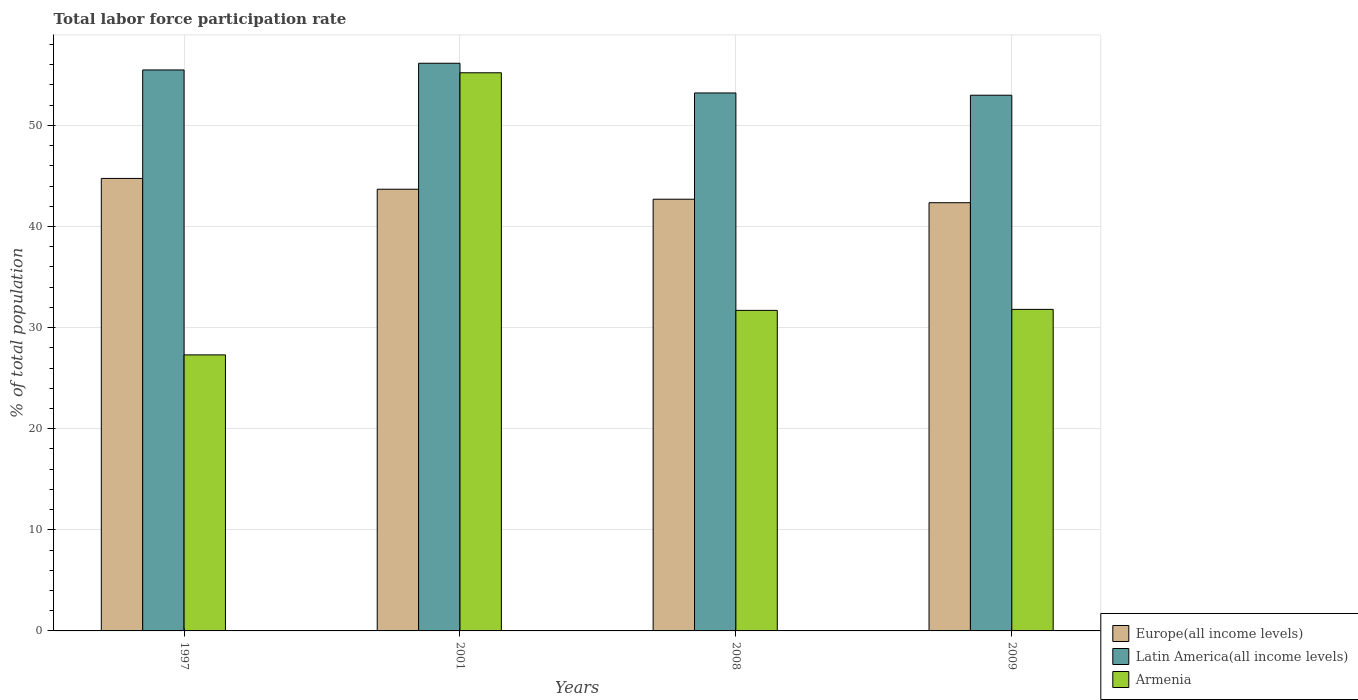How many different coloured bars are there?
Ensure brevity in your answer.  3. How many groups of bars are there?
Your answer should be compact. 4. Are the number of bars per tick equal to the number of legend labels?
Your response must be concise. Yes. How many bars are there on the 3rd tick from the left?
Make the answer very short. 3. What is the label of the 4th group of bars from the left?
Your answer should be very brief. 2009. In how many cases, is the number of bars for a given year not equal to the number of legend labels?
Your answer should be very brief. 0. What is the total labor force participation rate in Europe(all income levels) in 2001?
Offer a terse response. 43.68. Across all years, what is the maximum total labor force participation rate in Armenia?
Ensure brevity in your answer.  55.2. Across all years, what is the minimum total labor force participation rate in Armenia?
Offer a very short reply. 27.3. In which year was the total labor force participation rate in Armenia maximum?
Your answer should be compact. 2001. What is the total total labor force participation rate in Armenia in the graph?
Make the answer very short. 146. What is the difference between the total labor force participation rate in Latin America(all income levels) in 2001 and that in 2009?
Your answer should be very brief. 3.16. What is the difference between the total labor force participation rate in Armenia in 2001 and the total labor force participation rate in Latin America(all income levels) in 2009?
Your answer should be compact. 2.22. What is the average total labor force participation rate in Latin America(all income levels) per year?
Keep it short and to the point. 54.45. In the year 2008, what is the difference between the total labor force participation rate in Armenia and total labor force participation rate in Europe(all income levels)?
Keep it short and to the point. -10.99. What is the ratio of the total labor force participation rate in Latin America(all income levels) in 2008 to that in 2009?
Your response must be concise. 1. What is the difference between the highest and the second highest total labor force participation rate in Latin America(all income levels)?
Provide a succinct answer. 0.66. What is the difference between the highest and the lowest total labor force participation rate in Latin America(all income levels)?
Ensure brevity in your answer.  3.16. What does the 1st bar from the left in 2009 represents?
Provide a short and direct response. Europe(all income levels). What does the 3rd bar from the right in 2008 represents?
Keep it short and to the point. Europe(all income levels). How many bars are there?
Make the answer very short. 12. Are all the bars in the graph horizontal?
Offer a terse response. No. Does the graph contain grids?
Offer a terse response. Yes. Where does the legend appear in the graph?
Your answer should be very brief. Bottom right. How are the legend labels stacked?
Give a very brief answer. Vertical. What is the title of the graph?
Your answer should be compact. Total labor force participation rate. Does "Vietnam" appear as one of the legend labels in the graph?
Provide a short and direct response. No. What is the label or title of the X-axis?
Your response must be concise. Years. What is the label or title of the Y-axis?
Offer a very short reply. % of total population. What is the % of total population of Europe(all income levels) in 1997?
Give a very brief answer. 44.75. What is the % of total population of Latin America(all income levels) in 1997?
Your response must be concise. 55.48. What is the % of total population in Armenia in 1997?
Give a very brief answer. 27.3. What is the % of total population of Europe(all income levels) in 2001?
Provide a short and direct response. 43.68. What is the % of total population of Latin America(all income levels) in 2001?
Offer a very short reply. 56.14. What is the % of total population of Armenia in 2001?
Keep it short and to the point. 55.2. What is the % of total population in Europe(all income levels) in 2008?
Ensure brevity in your answer.  42.69. What is the % of total population of Latin America(all income levels) in 2008?
Make the answer very short. 53.2. What is the % of total population in Armenia in 2008?
Make the answer very short. 31.7. What is the % of total population in Europe(all income levels) in 2009?
Your response must be concise. 42.35. What is the % of total population of Latin America(all income levels) in 2009?
Keep it short and to the point. 52.98. What is the % of total population of Armenia in 2009?
Your answer should be compact. 31.8. Across all years, what is the maximum % of total population of Europe(all income levels)?
Provide a succinct answer. 44.75. Across all years, what is the maximum % of total population in Latin America(all income levels)?
Provide a succinct answer. 56.14. Across all years, what is the maximum % of total population of Armenia?
Provide a succinct answer. 55.2. Across all years, what is the minimum % of total population of Europe(all income levels)?
Your answer should be very brief. 42.35. Across all years, what is the minimum % of total population of Latin America(all income levels)?
Provide a succinct answer. 52.98. Across all years, what is the minimum % of total population in Armenia?
Give a very brief answer. 27.3. What is the total % of total population in Europe(all income levels) in the graph?
Provide a succinct answer. 173.48. What is the total % of total population in Latin America(all income levels) in the graph?
Provide a succinct answer. 217.8. What is the total % of total population in Armenia in the graph?
Ensure brevity in your answer.  146. What is the difference between the % of total population in Europe(all income levels) in 1997 and that in 2001?
Your answer should be very brief. 1.07. What is the difference between the % of total population of Latin America(all income levels) in 1997 and that in 2001?
Ensure brevity in your answer.  -0.66. What is the difference between the % of total population in Armenia in 1997 and that in 2001?
Your answer should be compact. -27.9. What is the difference between the % of total population of Europe(all income levels) in 1997 and that in 2008?
Your response must be concise. 2.06. What is the difference between the % of total population in Latin America(all income levels) in 1997 and that in 2008?
Provide a short and direct response. 2.27. What is the difference between the % of total population of Europe(all income levels) in 1997 and that in 2009?
Your response must be concise. 2.4. What is the difference between the % of total population of Latin America(all income levels) in 1997 and that in 2009?
Your answer should be compact. 2.5. What is the difference between the % of total population in Armenia in 1997 and that in 2009?
Offer a very short reply. -4.5. What is the difference between the % of total population of Europe(all income levels) in 2001 and that in 2008?
Your response must be concise. 0.99. What is the difference between the % of total population in Latin America(all income levels) in 2001 and that in 2008?
Offer a very short reply. 2.94. What is the difference between the % of total population in Armenia in 2001 and that in 2008?
Ensure brevity in your answer.  23.5. What is the difference between the % of total population in Europe(all income levels) in 2001 and that in 2009?
Your answer should be compact. 1.33. What is the difference between the % of total population of Latin America(all income levels) in 2001 and that in 2009?
Provide a succinct answer. 3.16. What is the difference between the % of total population in Armenia in 2001 and that in 2009?
Your answer should be compact. 23.4. What is the difference between the % of total population of Europe(all income levels) in 2008 and that in 2009?
Your response must be concise. 0.34. What is the difference between the % of total population of Latin America(all income levels) in 2008 and that in 2009?
Your answer should be compact. 0.23. What is the difference between the % of total population in Europe(all income levels) in 1997 and the % of total population in Latin America(all income levels) in 2001?
Offer a terse response. -11.39. What is the difference between the % of total population in Europe(all income levels) in 1997 and the % of total population in Armenia in 2001?
Give a very brief answer. -10.45. What is the difference between the % of total population of Latin America(all income levels) in 1997 and the % of total population of Armenia in 2001?
Provide a short and direct response. 0.28. What is the difference between the % of total population in Europe(all income levels) in 1997 and the % of total population in Latin America(all income levels) in 2008?
Your answer should be very brief. -8.45. What is the difference between the % of total population of Europe(all income levels) in 1997 and the % of total population of Armenia in 2008?
Your response must be concise. 13.05. What is the difference between the % of total population of Latin America(all income levels) in 1997 and the % of total population of Armenia in 2008?
Your answer should be compact. 23.78. What is the difference between the % of total population of Europe(all income levels) in 1997 and the % of total population of Latin America(all income levels) in 2009?
Provide a succinct answer. -8.23. What is the difference between the % of total population in Europe(all income levels) in 1997 and the % of total population in Armenia in 2009?
Keep it short and to the point. 12.95. What is the difference between the % of total population in Latin America(all income levels) in 1997 and the % of total population in Armenia in 2009?
Keep it short and to the point. 23.68. What is the difference between the % of total population of Europe(all income levels) in 2001 and the % of total population of Latin America(all income levels) in 2008?
Make the answer very short. -9.52. What is the difference between the % of total population of Europe(all income levels) in 2001 and the % of total population of Armenia in 2008?
Offer a very short reply. 11.98. What is the difference between the % of total population in Latin America(all income levels) in 2001 and the % of total population in Armenia in 2008?
Keep it short and to the point. 24.44. What is the difference between the % of total population of Europe(all income levels) in 2001 and the % of total population of Latin America(all income levels) in 2009?
Your response must be concise. -9.3. What is the difference between the % of total population of Europe(all income levels) in 2001 and the % of total population of Armenia in 2009?
Offer a terse response. 11.88. What is the difference between the % of total population of Latin America(all income levels) in 2001 and the % of total population of Armenia in 2009?
Provide a short and direct response. 24.34. What is the difference between the % of total population in Europe(all income levels) in 2008 and the % of total population in Latin America(all income levels) in 2009?
Provide a short and direct response. -10.29. What is the difference between the % of total population in Europe(all income levels) in 2008 and the % of total population in Armenia in 2009?
Your answer should be compact. 10.89. What is the difference between the % of total population of Latin America(all income levels) in 2008 and the % of total population of Armenia in 2009?
Provide a succinct answer. 21.4. What is the average % of total population of Europe(all income levels) per year?
Offer a very short reply. 43.37. What is the average % of total population of Latin America(all income levels) per year?
Give a very brief answer. 54.45. What is the average % of total population of Armenia per year?
Make the answer very short. 36.5. In the year 1997, what is the difference between the % of total population in Europe(all income levels) and % of total population in Latin America(all income levels)?
Provide a succinct answer. -10.73. In the year 1997, what is the difference between the % of total population in Europe(all income levels) and % of total population in Armenia?
Provide a short and direct response. 17.45. In the year 1997, what is the difference between the % of total population in Latin America(all income levels) and % of total population in Armenia?
Provide a short and direct response. 28.18. In the year 2001, what is the difference between the % of total population of Europe(all income levels) and % of total population of Latin America(all income levels)?
Your response must be concise. -12.46. In the year 2001, what is the difference between the % of total population in Europe(all income levels) and % of total population in Armenia?
Make the answer very short. -11.52. In the year 2001, what is the difference between the % of total population of Latin America(all income levels) and % of total population of Armenia?
Give a very brief answer. 0.94. In the year 2008, what is the difference between the % of total population of Europe(all income levels) and % of total population of Latin America(all income levels)?
Your response must be concise. -10.51. In the year 2008, what is the difference between the % of total population in Europe(all income levels) and % of total population in Armenia?
Keep it short and to the point. 10.99. In the year 2008, what is the difference between the % of total population of Latin America(all income levels) and % of total population of Armenia?
Provide a short and direct response. 21.5. In the year 2009, what is the difference between the % of total population of Europe(all income levels) and % of total population of Latin America(all income levels)?
Provide a succinct answer. -10.63. In the year 2009, what is the difference between the % of total population of Europe(all income levels) and % of total population of Armenia?
Give a very brief answer. 10.55. In the year 2009, what is the difference between the % of total population in Latin America(all income levels) and % of total population in Armenia?
Give a very brief answer. 21.18. What is the ratio of the % of total population of Europe(all income levels) in 1997 to that in 2001?
Give a very brief answer. 1.02. What is the ratio of the % of total population in Latin America(all income levels) in 1997 to that in 2001?
Offer a terse response. 0.99. What is the ratio of the % of total population of Armenia in 1997 to that in 2001?
Provide a short and direct response. 0.49. What is the ratio of the % of total population in Europe(all income levels) in 1997 to that in 2008?
Give a very brief answer. 1.05. What is the ratio of the % of total population in Latin America(all income levels) in 1997 to that in 2008?
Your response must be concise. 1.04. What is the ratio of the % of total population in Armenia in 1997 to that in 2008?
Keep it short and to the point. 0.86. What is the ratio of the % of total population of Europe(all income levels) in 1997 to that in 2009?
Offer a very short reply. 1.06. What is the ratio of the % of total population in Latin America(all income levels) in 1997 to that in 2009?
Provide a succinct answer. 1.05. What is the ratio of the % of total population of Armenia in 1997 to that in 2009?
Offer a very short reply. 0.86. What is the ratio of the % of total population in Europe(all income levels) in 2001 to that in 2008?
Offer a terse response. 1.02. What is the ratio of the % of total population of Latin America(all income levels) in 2001 to that in 2008?
Your response must be concise. 1.06. What is the ratio of the % of total population of Armenia in 2001 to that in 2008?
Keep it short and to the point. 1.74. What is the ratio of the % of total population of Europe(all income levels) in 2001 to that in 2009?
Your answer should be very brief. 1.03. What is the ratio of the % of total population of Latin America(all income levels) in 2001 to that in 2009?
Keep it short and to the point. 1.06. What is the ratio of the % of total population in Armenia in 2001 to that in 2009?
Your answer should be compact. 1.74. What is the ratio of the % of total population in Europe(all income levels) in 2008 to that in 2009?
Your answer should be very brief. 1.01. What is the ratio of the % of total population in Latin America(all income levels) in 2008 to that in 2009?
Make the answer very short. 1. What is the ratio of the % of total population of Armenia in 2008 to that in 2009?
Offer a very short reply. 1. What is the difference between the highest and the second highest % of total population in Europe(all income levels)?
Provide a succinct answer. 1.07. What is the difference between the highest and the second highest % of total population of Latin America(all income levels)?
Ensure brevity in your answer.  0.66. What is the difference between the highest and the second highest % of total population in Armenia?
Your response must be concise. 23.4. What is the difference between the highest and the lowest % of total population of Europe(all income levels)?
Make the answer very short. 2.4. What is the difference between the highest and the lowest % of total population of Latin America(all income levels)?
Offer a very short reply. 3.16. What is the difference between the highest and the lowest % of total population of Armenia?
Your answer should be compact. 27.9. 